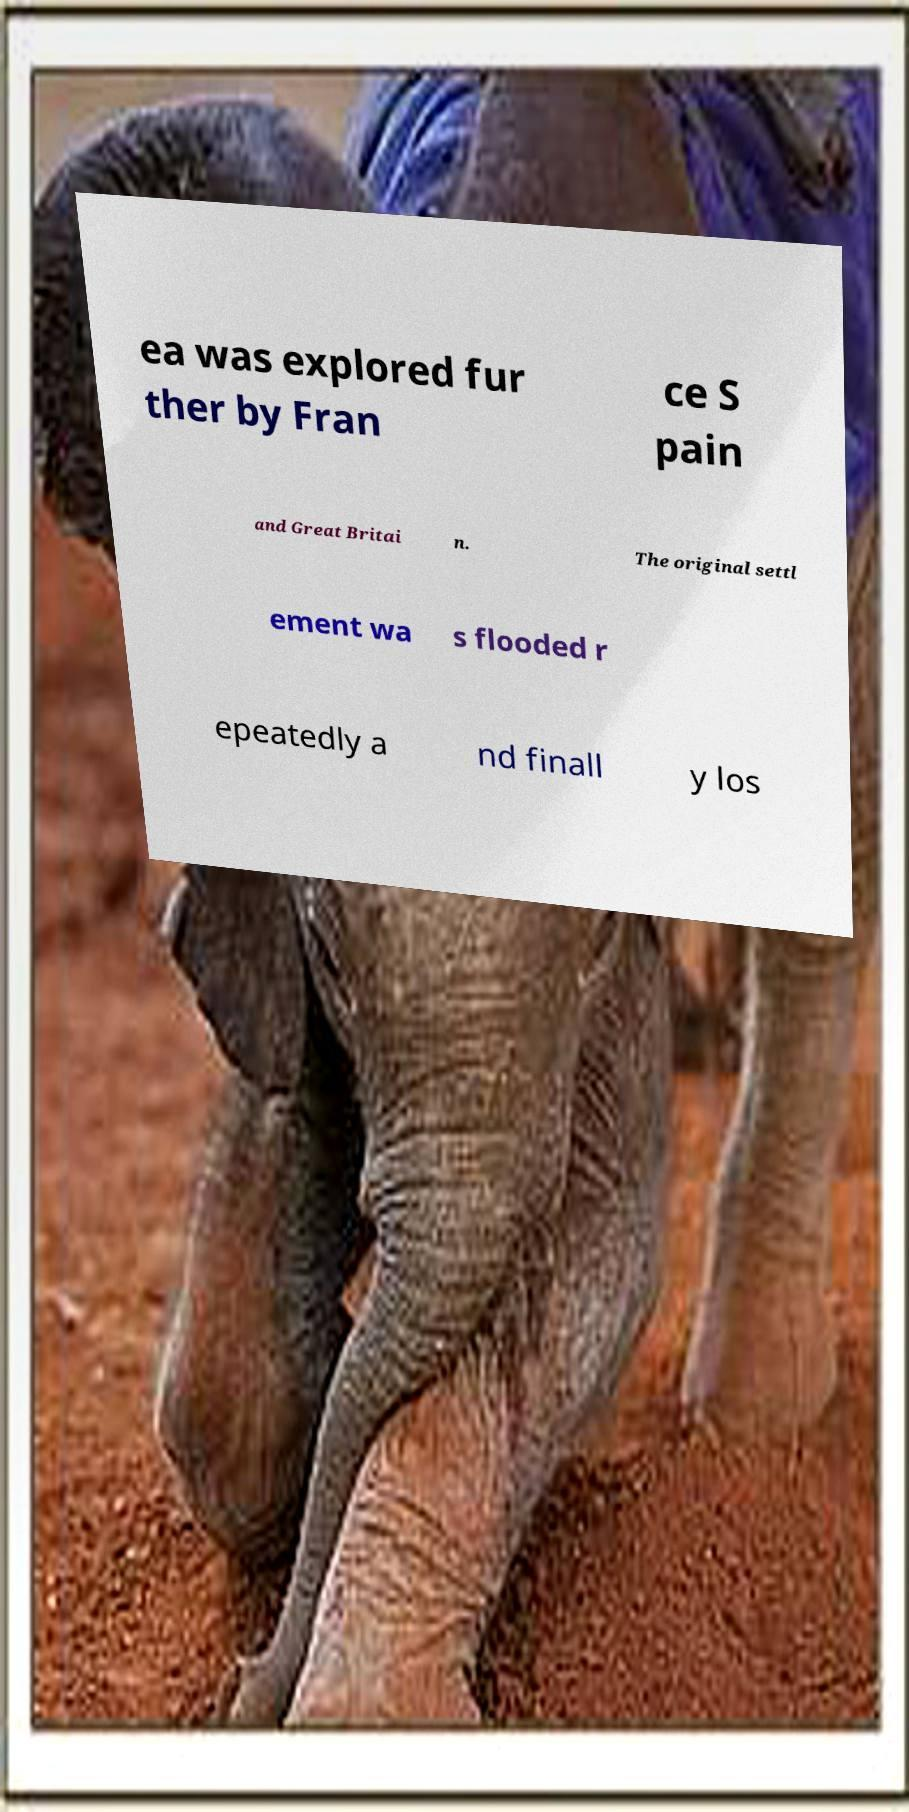Could you extract and type out the text from this image? ea was explored fur ther by Fran ce S pain and Great Britai n. The original settl ement wa s flooded r epeatedly a nd finall y los 